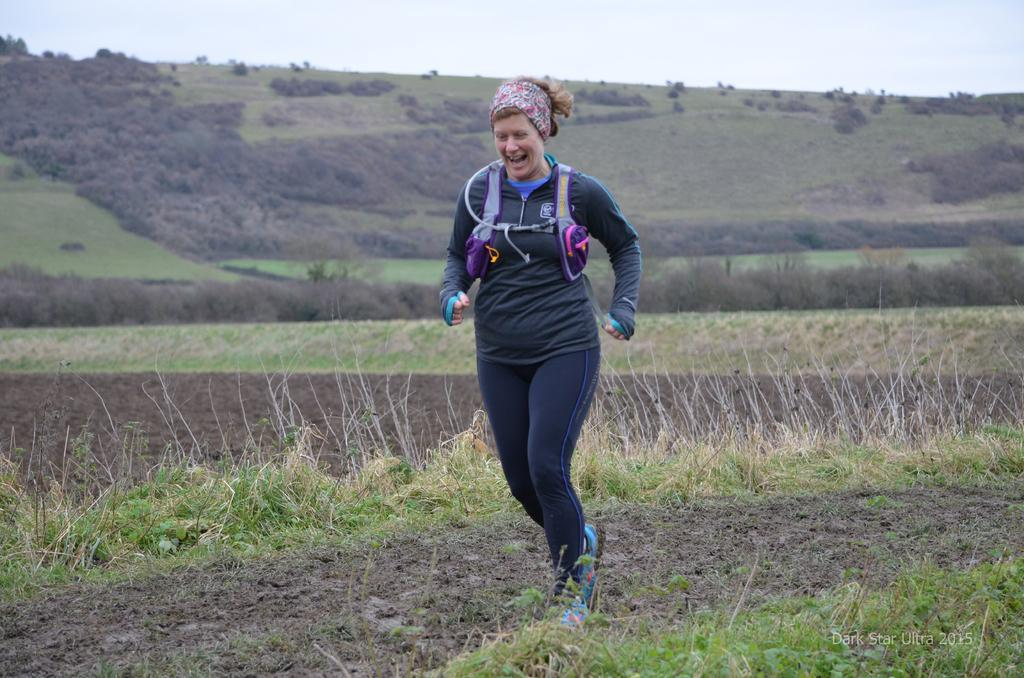Who is the main subject in the image? There is a woman in the image. What is the woman doing in the image? The woman is running. What type of terrain is visible in the image? There is grass on the ground in the image. What can be seen in the background of the image? There are trees visible in the image. How would you describe the weather in the image? The sky is cloudy in the image. What is the woman wearing on her head? The woman is wearing a headband. Where is the notebook that the woman is using to take notes in the image? There is no notebook present in the image; the woman is running and not taking notes. What type of respect is being shown by the woman in the image? There is no indication of respect being shown in the image, as the woman is running and not interacting with anyone or anything. 